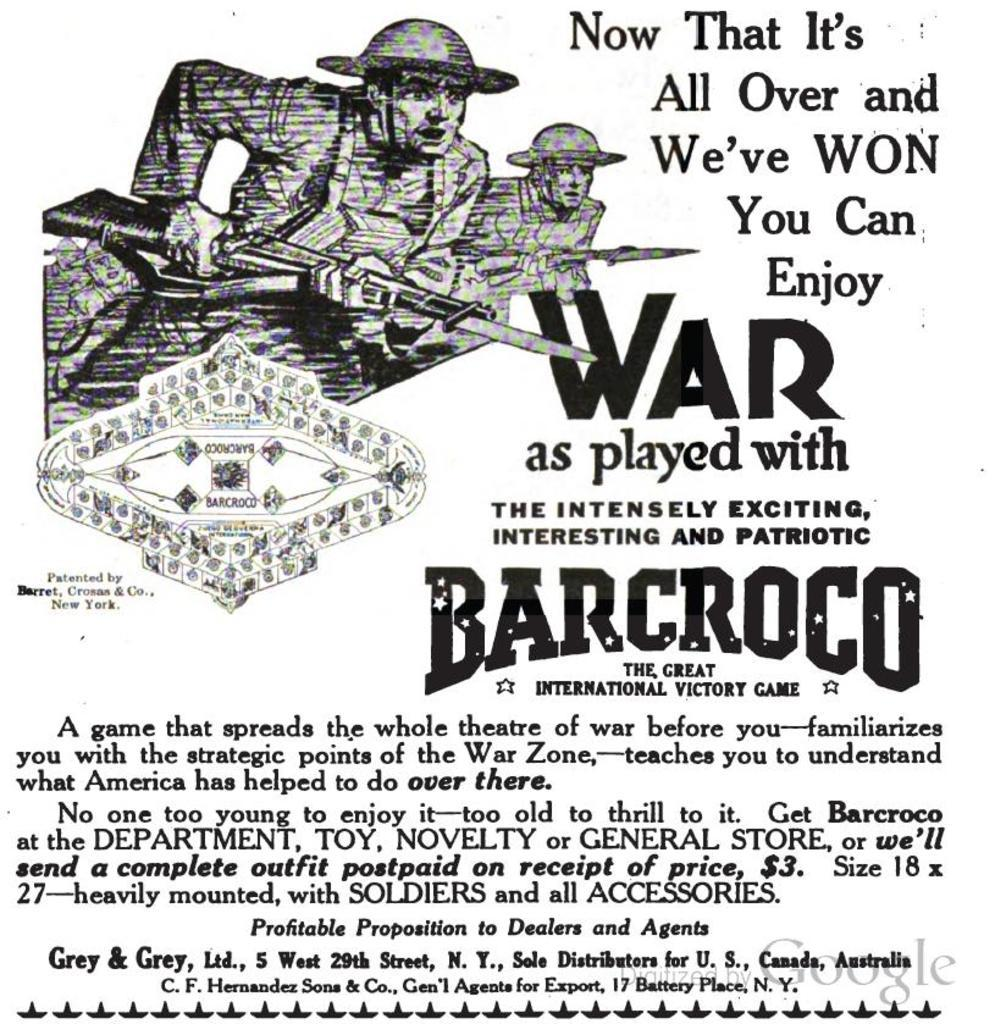<image>
Relay a brief, clear account of the picture shown. An advert for the production titled War as played with barcroco. 